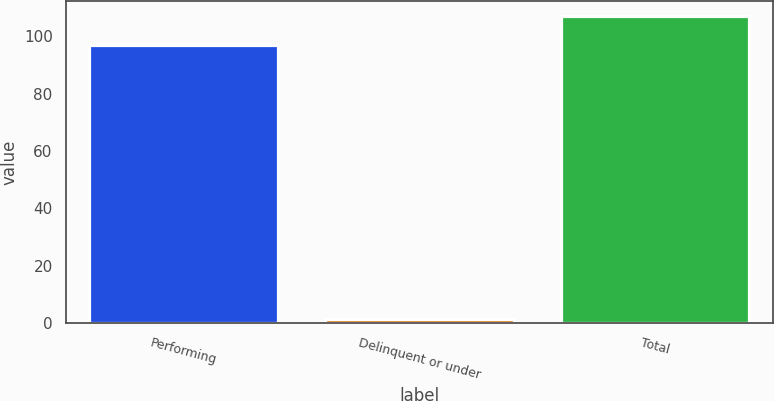Convert chart. <chart><loc_0><loc_0><loc_500><loc_500><bar_chart><fcel>Performing<fcel>Delinquent or under<fcel>Total<nl><fcel>97.1<fcel>1.5<fcel>106.95<nl></chart> 